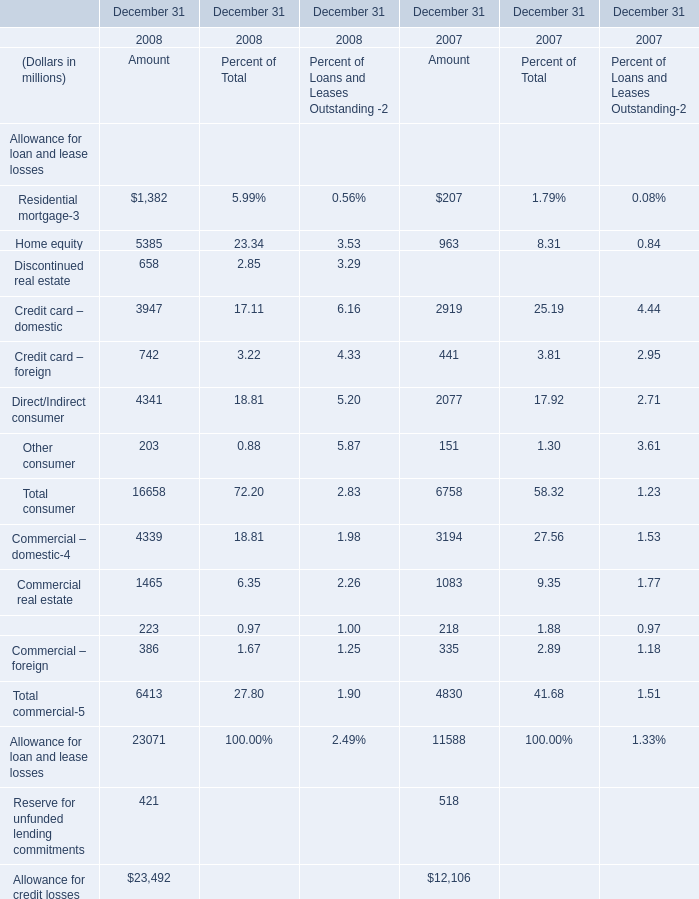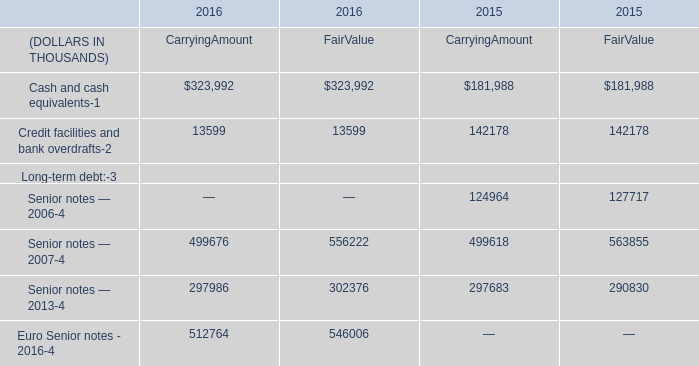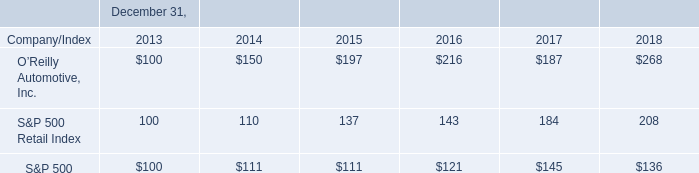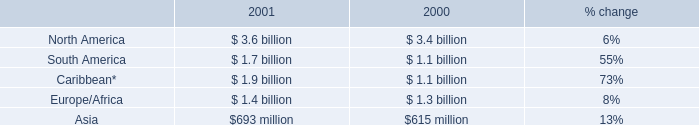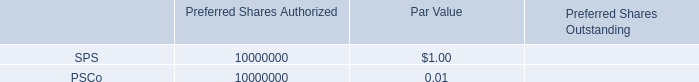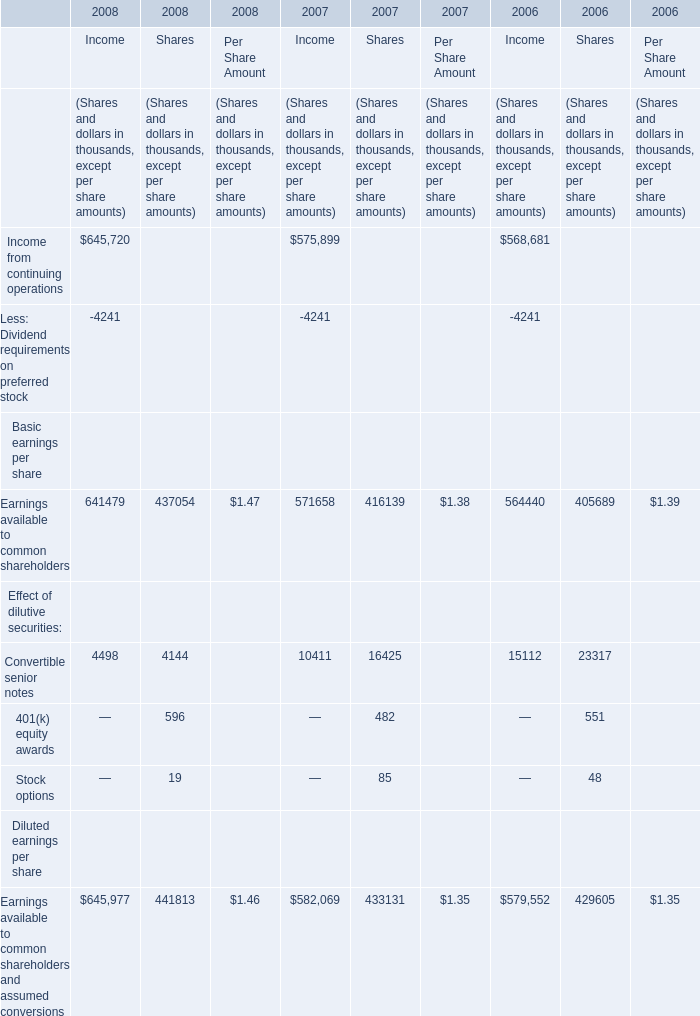What's the total amount of Home equity in the range of 3 and 5385 in 2008? (in million) 
Computations: ((5385 + 23.34) + 3.53)
Answer: 5411.87. 